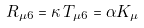Convert formula to latex. <formula><loc_0><loc_0><loc_500><loc_500>R _ { \mu 6 } = \kappa \, T _ { \mu 6 } = \alpha K _ { \mu }</formula> 